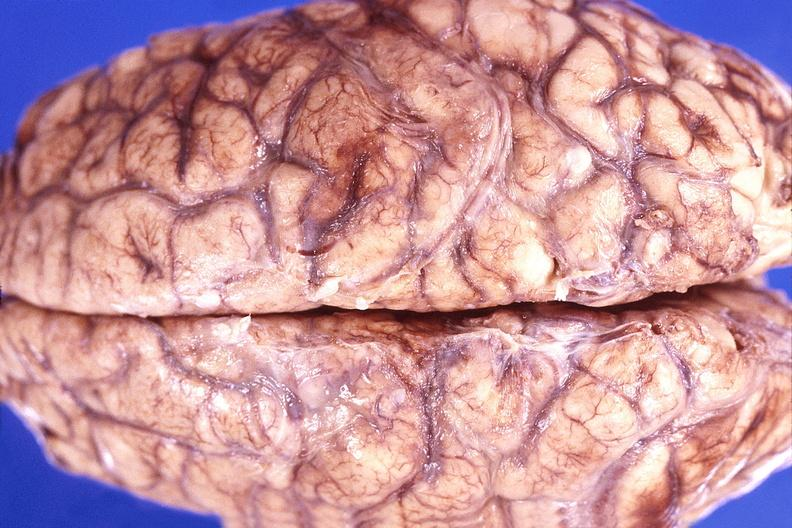does history show brain abscess?
Answer the question using a single word or phrase. No 